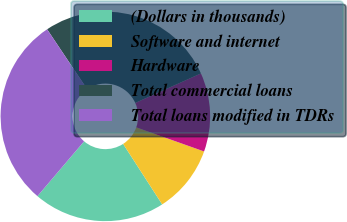Convert chart to OTSL. <chart><loc_0><loc_0><loc_500><loc_500><pie_chart><fcel>(Dollars in thousands)<fcel>Software and internet<fcel>Hardware<fcel>Total commercial loans<fcel>Total loans modified in TDRs<nl><fcel>20.35%<fcel>10.44%<fcel>12.16%<fcel>27.66%<fcel>29.39%<nl></chart> 